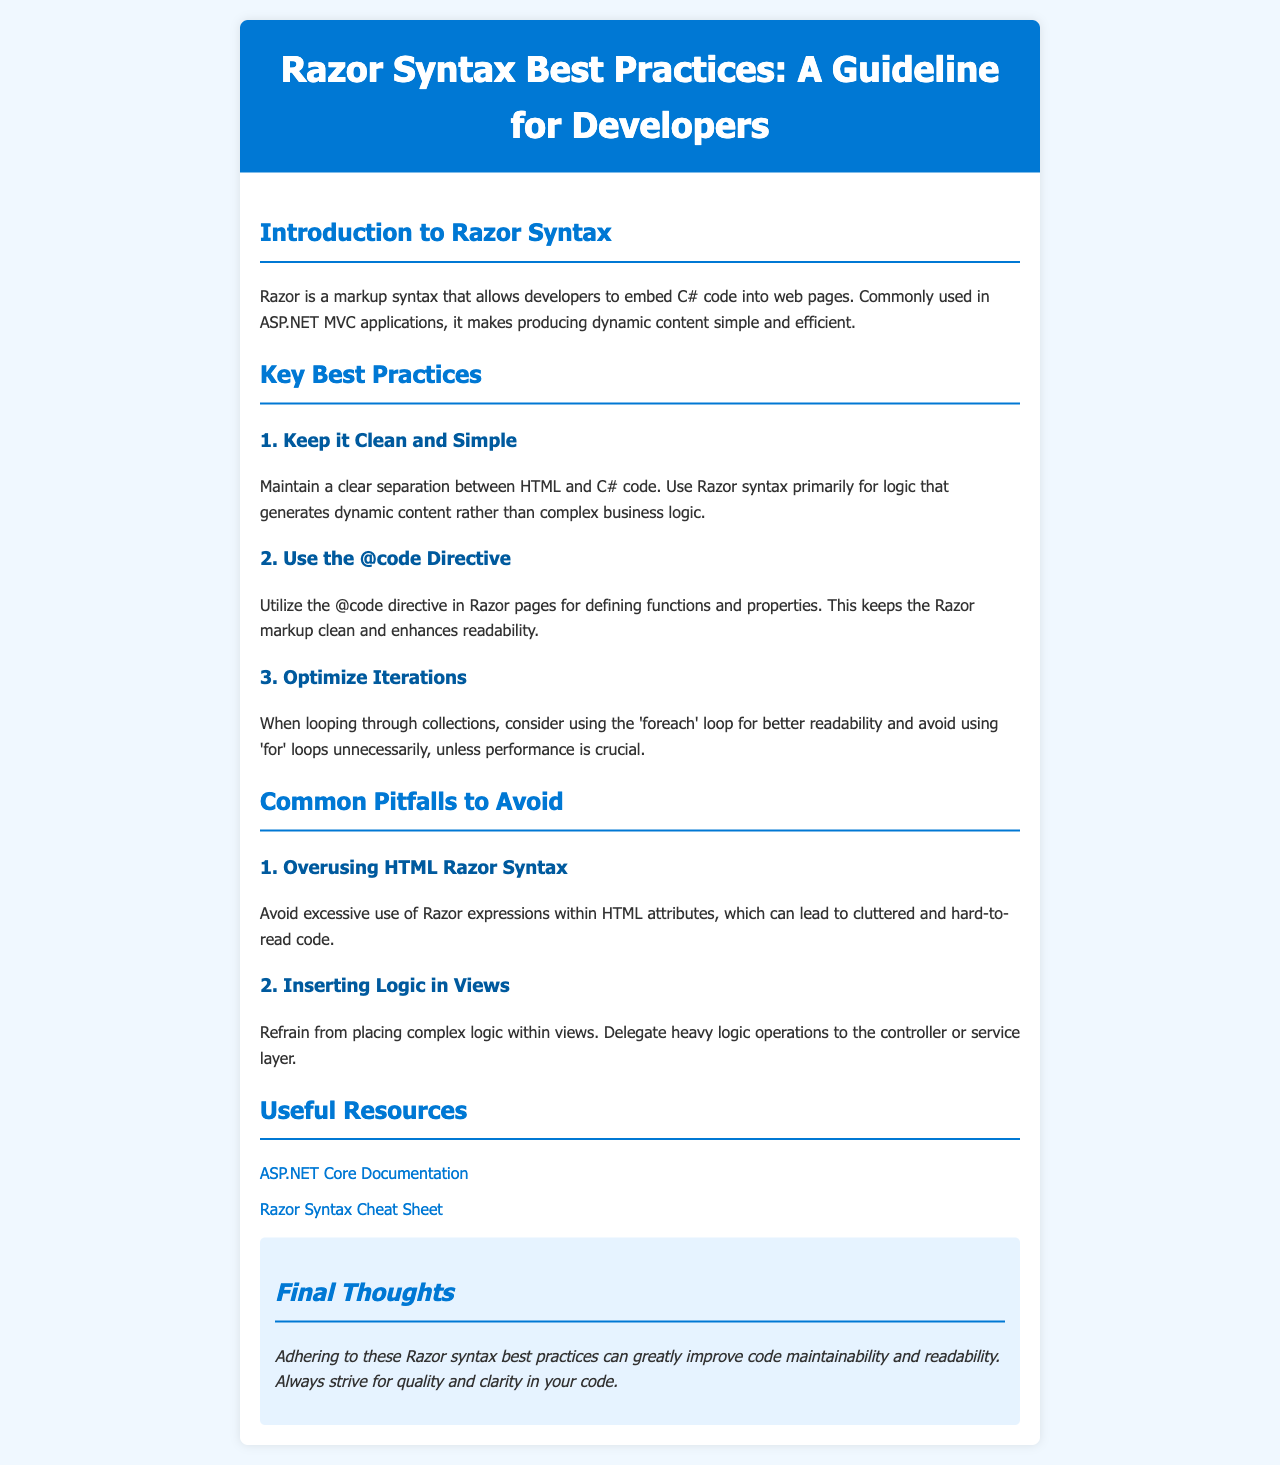what is the title of the document? The title is the main heading prominently displayed at the top of the document.
Answer: Razor Syntax Best Practices: A Guideline for Developers how many key best practices are listed? The number of key best practices is indicated in the section header and the list underneath.
Answer: 3 what is the first key best practice? The first key best practice is presented as the first list item in the designated section.
Answer: Keep it Clean and Simple which section comes after "Common Pitfalls to Avoid"? The section order indicates the sequence of contents listed in the brochure.
Answer: Useful Resources what is one of the useful resources linked in the document? This resource is listed under the Useful Resources section and contains a hyperlink.
Answer: ASP.NET Core Documentation what does the final thoughts section emphasize? The final thoughts section encapsulates the main takeaway from the brochure.
Answer: Quality and clarity in your code what should be avoided to maintain clean code? This is highlighted in the best practices section, encapsulating a key guideline.
Answer: Overusing HTML Razor Syntax what is suggested for looping through collections? This recommendation is found in the key best practices section to enhance code readability.
Answer: Use the foreach loop 